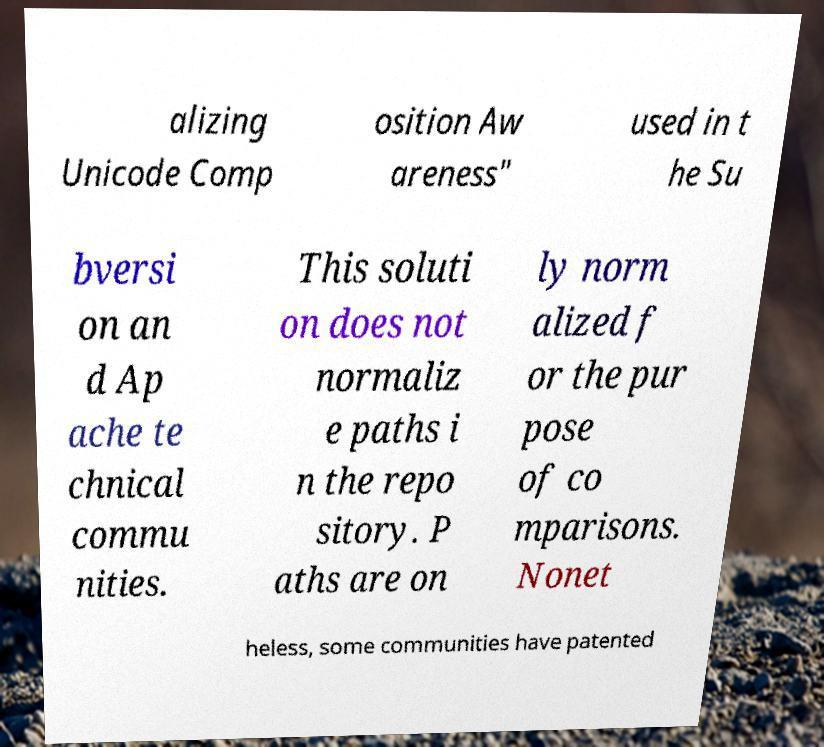Can you read and provide the text displayed in the image?This photo seems to have some interesting text. Can you extract and type it out for me? alizing Unicode Comp osition Aw areness" used in t he Su bversi on an d Ap ache te chnical commu nities. This soluti on does not normaliz e paths i n the repo sitory. P aths are on ly norm alized f or the pur pose of co mparisons. Nonet heless, some communities have patented 